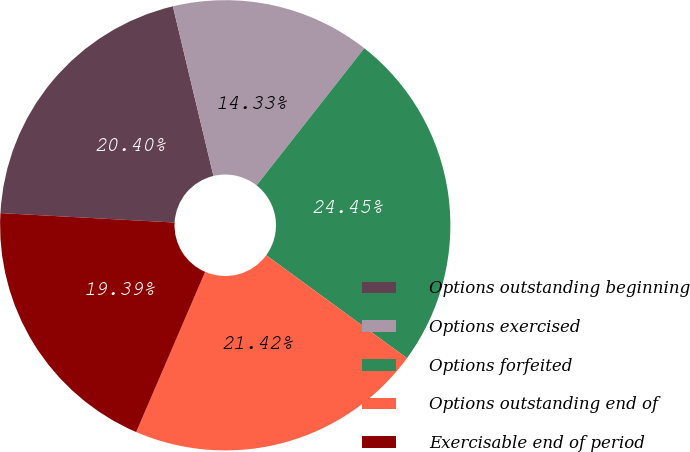<chart> <loc_0><loc_0><loc_500><loc_500><pie_chart><fcel>Options outstanding beginning<fcel>Options exercised<fcel>Options forfeited<fcel>Options outstanding end of<fcel>Exercisable end of period<nl><fcel>20.4%<fcel>14.33%<fcel>24.45%<fcel>21.42%<fcel>19.39%<nl></chart> 